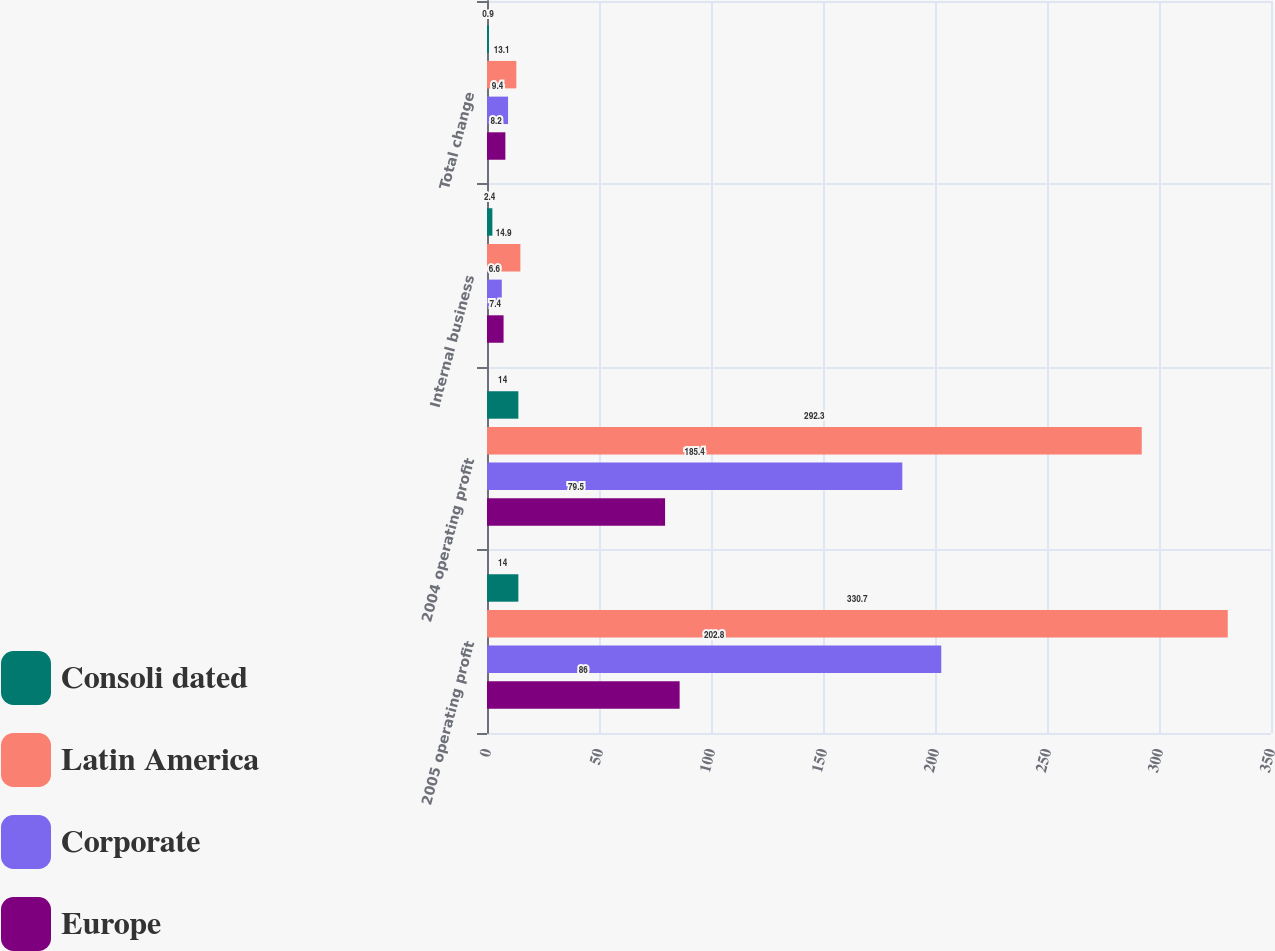Convert chart to OTSL. <chart><loc_0><loc_0><loc_500><loc_500><stacked_bar_chart><ecel><fcel>2005 operating profit<fcel>2004 operating profit<fcel>Internal business<fcel>Total change<nl><fcel>Consoli dated<fcel>14<fcel>14<fcel>2.4<fcel>0.9<nl><fcel>Latin America<fcel>330.7<fcel>292.3<fcel>14.9<fcel>13.1<nl><fcel>Corporate<fcel>202.8<fcel>185.4<fcel>6.6<fcel>9.4<nl><fcel>Europe<fcel>86<fcel>79.5<fcel>7.4<fcel>8.2<nl></chart> 